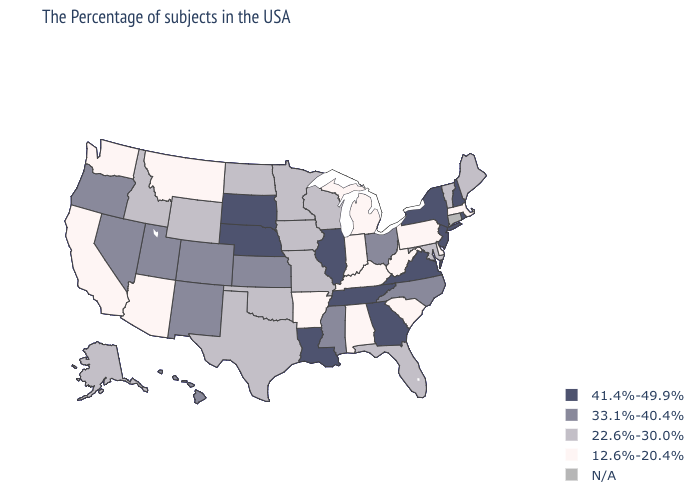What is the lowest value in the Northeast?
Answer briefly. 12.6%-20.4%. Name the states that have a value in the range 41.4%-49.9%?
Concise answer only. Rhode Island, New Hampshire, New York, New Jersey, Virginia, Georgia, Tennessee, Illinois, Louisiana, Nebraska, South Dakota. Name the states that have a value in the range 33.1%-40.4%?
Give a very brief answer. North Carolina, Ohio, Mississippi, Kansas, Colorado, New Mexico, Utah, Nevada, Oregon, Hawaii. What is the value of Mississippi?
Write a very short answer. 33.1%-40.4%. Which states have the lowest value in the USA?
Give a very brief answer. Massachusetts, Delaware, Pennsylvania, South Carolina, West Virginia, Michigan, Kentucky, Indiana, Alabama, Arkansas, Montana, Arizona, California, Washington. Does Tennessee have the lowest value in the USA?
Give a very brief answer. No. What is the highest value in states that border Oklahoma?
Give a very brief answer. 33.1%-40.4%. What is the value of Missouri?
Answer briefly. 22.6%-30.0%. Does New Jersey have the lowest value in the USA?
Give a very brief answer. No. Name the states that have a value in the range 33.1%-40.4%?
Concise answer only. North Carolina, Ohio, Mississippi, Kansas, Colorado, New Mexico, Utah, Nevada, Oregon, Hawaii. Name the states that have a value in the range N/A?
Be succinct. Connecticut. What is the lowest value in states that border Delaware?
Quick response, please. 12.6%-20.4%. What is the value of Tennessee?
Answer briefly. 41.4%-49.9%. What is the value of Maine?
Give a very brief answer. 22.6%-30.0%. Does the first symbol in the legend represent the smallest category?
Keep it brief. No. 